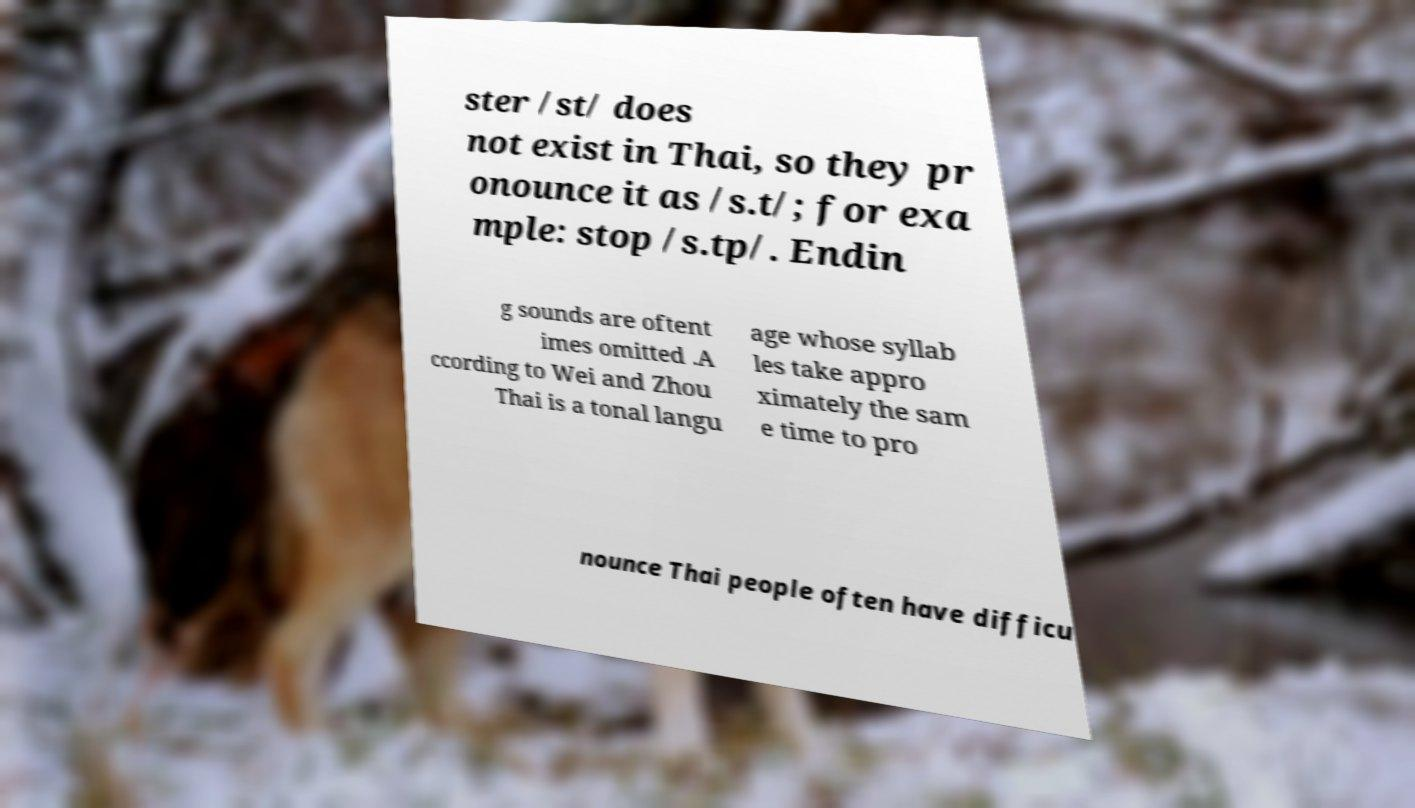Can you read and provide the text displayed in the image?This photo seems to have some interesting text. Can you extract and type it out for me? ster /st/ does not exist in Thai, so they pr onounce it as /s.t/; for exa mple: stop /s.tp/. Endin g sounds are oftent imes omitted .A ccording to Wei and Zhou Thai is a tonal langu age whose syllab les take appro ximately the sam e time to pro nounce Thai people often have difficu 